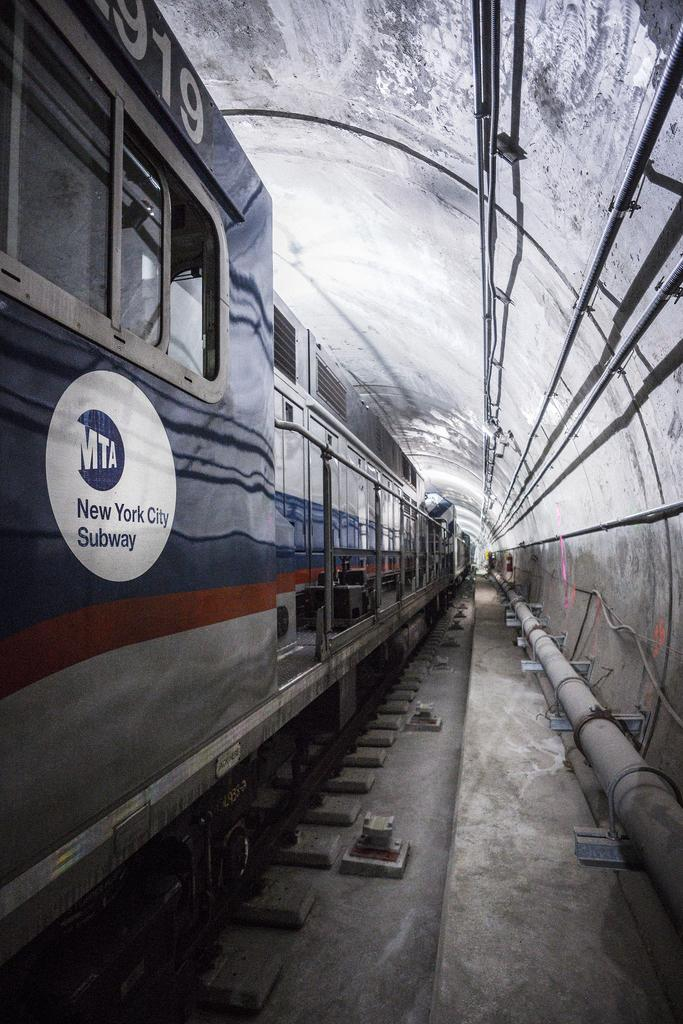What is the main subject of the image? The main subject of the image is a train. Where is the train located in the image? The train is on a track. What can be seen on the right side of the image? There is a wall on the right side of the image. What is connected to the wall in the image? Pipes are connected to the wall. What type of glue is being used to hold the train together in the image? There is no glue present in the image, and the train is not being held together by any glue. What is the cause of the train's movement in the image? The train's movement is not depicted in the image, so it is not possible to determine the cause of its movement. 